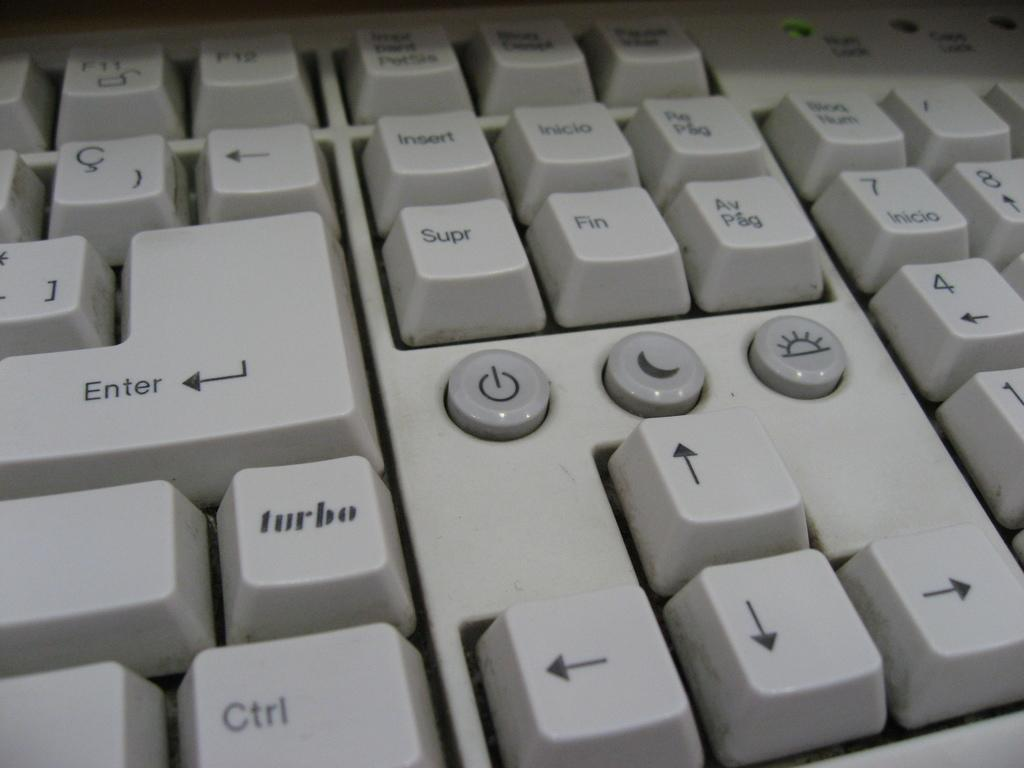<image>
Describe the image concisely. The turbo key is shown below the enter key on a white keyboard 